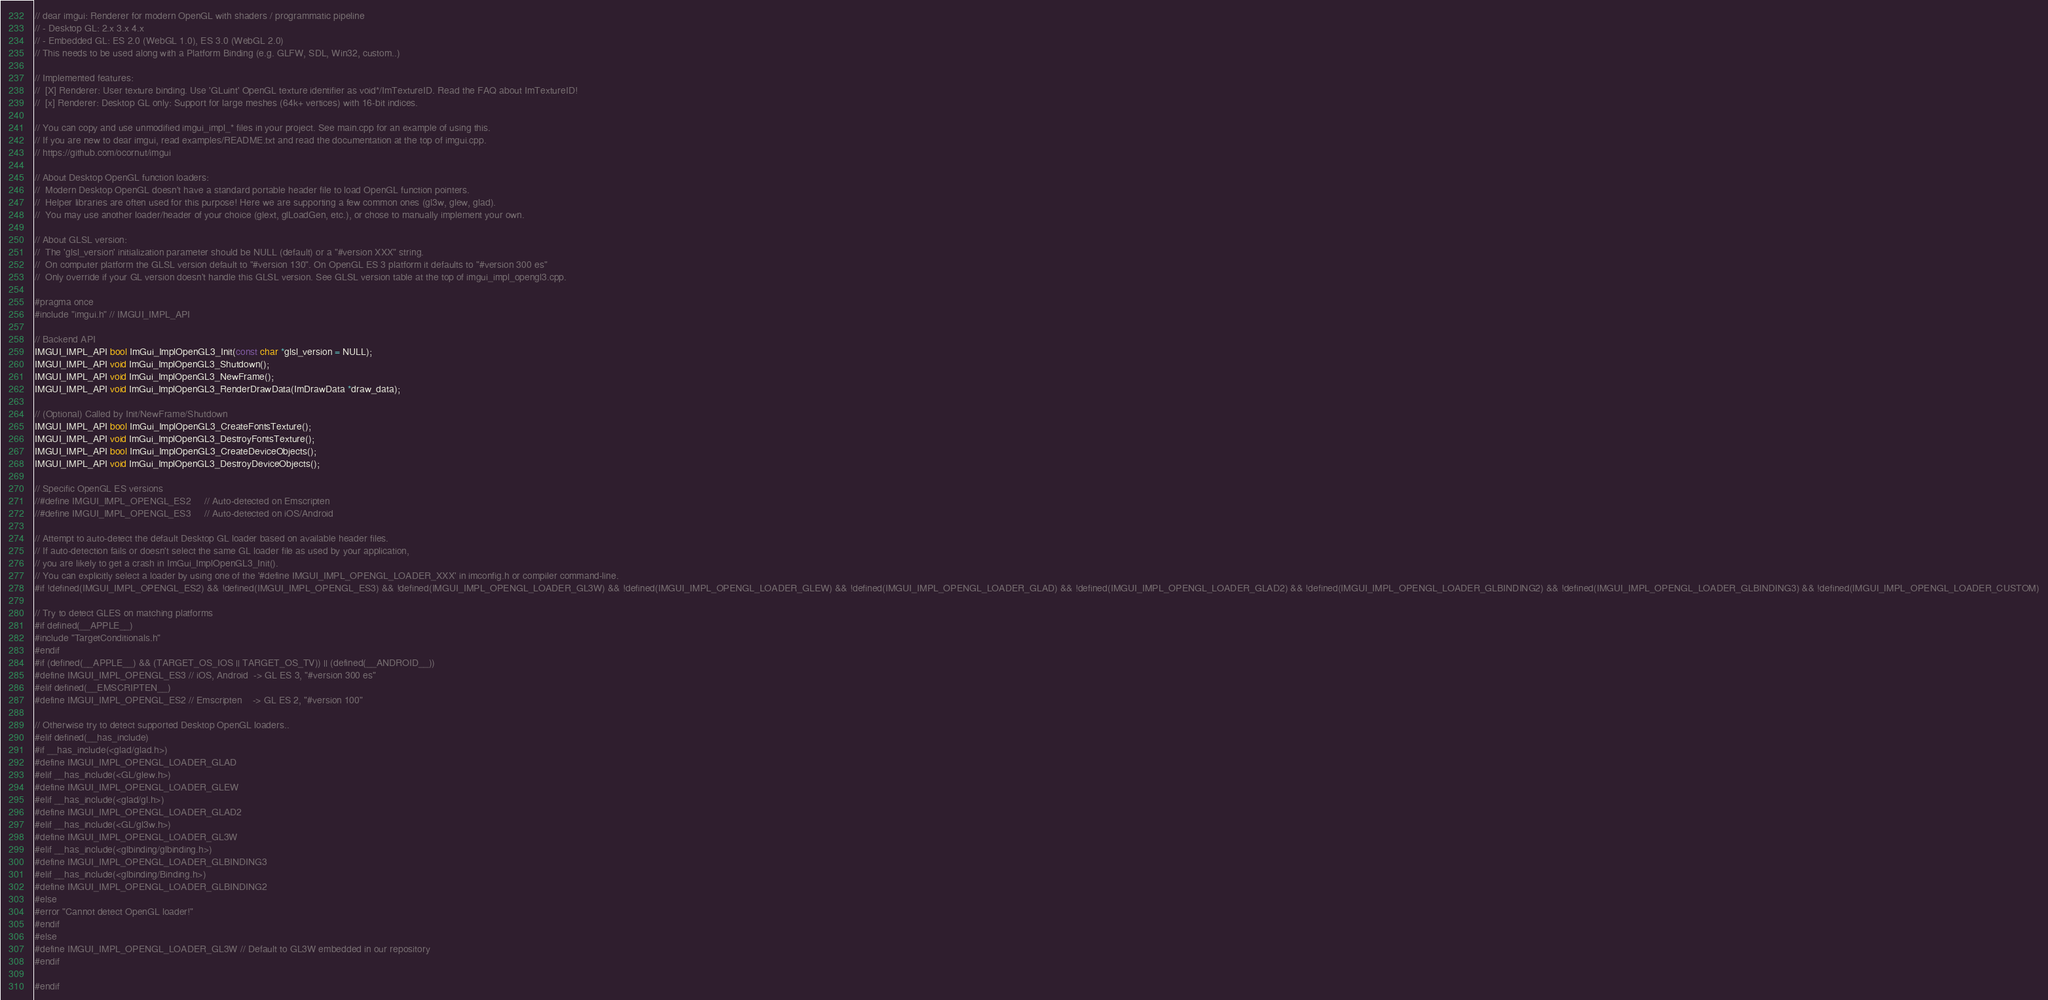Convert code to text. <code><loc_0><loc_0><loc_500><loc_500><_C_>// dear imgui: Renderer for modern OpenGL with shaders / programmatic pipeline
// - Desktop GL: 2.x 3.x 4.x
// - Embedded GL: ES 2.0 (WebGL 1.0), ES 3.0 (WebGL 2.0)
// This needs to be used along with a Platform Binding (e.g. GLFW, SDL, Win32, custom..)

// Implemented features:
//  [X] Renderer: User texture binding. Use 'GLuint' OpenGL texture identifier as void*/ImTextureID. Read the FAQ about ImTextureID!
//  [x] Renderer: Desktop GL only: Support for large meshes (64k+ vertices) with 16-bit indices.

// You can copy and use unmodified imgui_impl_* files in your project. See main.cpp for an example of using this.
// If you are new to dear imgui, read examples/README.txt and read the documentation at the top of imgui.cpp.
// https://github.com/ocornut/imgui

// About Desktop OpenGL function loaders:
//  Modern Desktop OpenGL doesn't have a standard portable header file to load OpenGL function pointers.
//  Helper libraries are often used for this purpose! Here we are supporting a few common ones (gl3w, glew, glad).
//  You may use another loader/header of your choice (glext, glLoadGen, etc.), or chose to manually implement your own.

// About GLSL version:
//  The 'glsl_version' initialization parameter should be NULL (default) or a "#version XXX" string.
//  On computer platform the GLSL version default to "#version 130". On OpenGL ES 3 platform it defaults to "#version 300 es"
//  Only override if your GL version doesn't handle this GLSL version. See GLSL version table at the top of imgui_impl_opengl3.cpp.

#pragma once
#include "imgui.h" // IMGUI_IMPL_API

// Backend API
IMGUI_IMPL_API bool ImGui_ImplOpenGL3_Init(const char *glsl_version = NULL);
IMGUI_IMPL_API void ImGui_ImplOpenGL3_Shutdown();
IMGUI_IMPL_API void ImGui_ImplOpenGL3_NewFrame();
IMGUI_IMPL_API void ImGui_ImplOpenGL3_RenderDrawData(ImDrawData *draw_data);

// (Optional) Called by Init/NewFrame/Shutdown
IMGUI_IMPL_API bool ImGui_ImplOpenGL3_CreateFontsTexture();
IMGUI_IMPL_API void ImGui_ImplOpenGL3_DestroyFontsTexture();
IMGUI_IMPL_API bool ImGui_ImplOpenGL3_CreateDeviceObjects();
IMGUI_IMPL_API void ImGui_ImplOpenGL3_DestroyDeviceObjects();

// Specific OpenGL ES versions
//#define IMGUI_IMPL_OPENGL_ES2     // Auto-detected on Emscripten
//#define IMGUI_IMPL_OPENGL_ES3     // Auto-detected on iOS/Android

// Attempt to auto-detect the default Desktop GL loader based on available header files.
// If auto-detection fails or doesn't select the same GL loader file as used by your application,
// you are likely to get a crash in ImGui_ImplOpenGL3_Init().
// You can explicitly select a loader by using one of the '#define IMGUI_IMPL_OPENGL_LOADER_XXX' in imconfig.h or compiler command-line.
#if !defined(IMGUI_IMPL_OPENGL_ES2) && !defined(IMGUI_IMPL_OPENGL_ES3) && !defined(IMGUI_IMPL_OPENGL_LOADER_GL3W) && !defined(IMGUI_IMPL_OPENGL_LOADER_GLEW) && !defined(IMGUI_IMPL_OPENGL_LOADER_GLAD) && !defined(IMGUI_IMPL_OPENGL_LOADER_GLAD2) && !defined(IMGUI_IMPL_OPENGL_LOADER_GLBINDING2) && !defined(IMGUI_IMPL_OPENGL_LOADER_GLBINDING3) && !defined(IMGUI_IMPL_OPENGL_LOADER_CUSTOM)

// Try to detect GLES on matching platforms
#if defined(__APPLE__)
#include "TargetConditionals.h"
#endif
#if (defined(__APPLE__) && (TARGET_OS_IOS || TARGET_OS_TV)) || (defined(__ANDROID__))
#define IMGUI_IMPL_OPENGL_ES3 // iOS, Android  -> GL ES 3, "#version 300 es"
#elif defined(__EMSCRIPTEN__)
#define IMGUI_IMPL_OPENGL_ES2 // Emscripten    -> GL ES 2, "#version 100"

// Otherwise try to detect supported Desktop OpenGL loaders..
#elif defined(__has_include)
#if __has_include(<glad/glad.h>)
#define IMGUI_IMPL_OPENGL_LOADER_GLAD
#elif __has_include(<GL/glew.h>)
#define IMGUI_IMPL_OPENGL_LOADER_GLEW
#elif __has_include(<glad/gl.h>)
#define IMGUI_IMPL_OPENGL_LOADER_GLAD2
#elif __has_include(<GL/gl3w.h>)
#define IMGUI_IMPL_OPENGL_LOADER_GL3W
#elif __has_include(<glbinding/glbinding.h>)
#define IMGUI_IMPL_OPENGL_LOADER_GLBINDING3
#elif __has_include(<glbinding/Binding.h>)
#define IMGUI_IMPL_OPENGL_LOADER_GLBINDING2
#else
#error "Cannot detect OpenGL loader!"
#endif
#else
#define IMGUI_IMPL_OPENGL_LOADER_GL3W // Default to GL3W embedded in our repository
#endif

#endif
</code> 